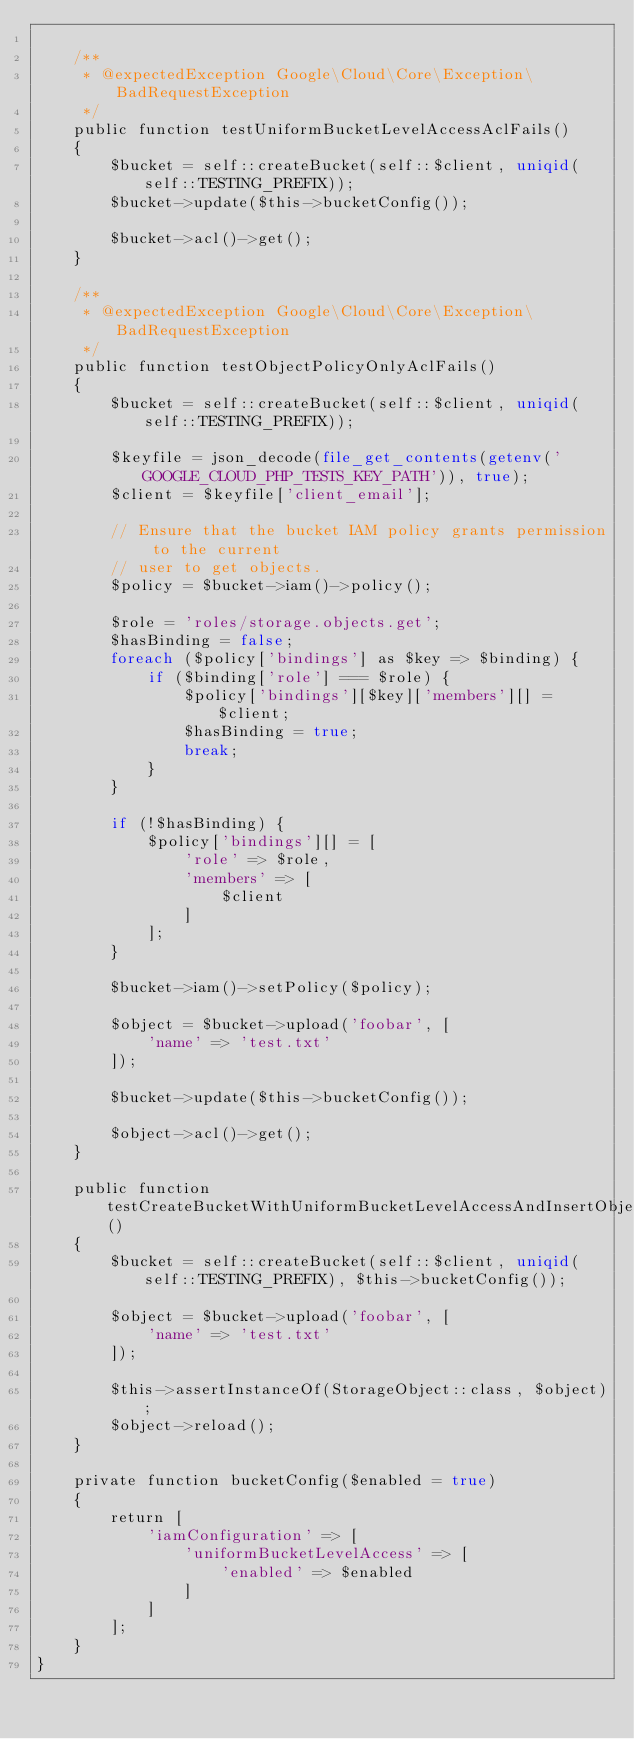Convert code to text. <code><loc_0><loc_0><loc_500><loc_500><_PHP_>
    /**
     * @expectedException Google\Cloud\Core\Exception\BadRequestException
     */
    public function testUniformBucketLevelAccessAclFails()
    {
        $bucket = self::createBucket(self::$client, uniqid(self::TESTING_PREFIX));
        $bucket->update($this->bucketConfig());

        $bucket->acl()->get();
    }

    /**
     * @expectedException Google\Cloud\Core\Exception\BadRequestException
     */
    public function testObjectPolicyOnlyAclFails()
    {
        $bucket = self::createBucket(self::$client, uniqid(self::TESTING_PREFIX));

        $keyfile = json_decode(file_get_contents(getenv('GOOGLE_CLOUD_PHP_TESTS_KEY_PATH')), true);
        $client = $keyfile['client_email'];

        // Ensure that the bucket IAM policy grants permission to the current
        // user to get objects.
        $policy = $bucket->iam()->policy();

        $role = 'roles/storage.objects.get';
        $hasBinding = false;
        foreach ($policy['bindings'] as $key => $binding) {
            if ($binding['role'] === $role) {
                $policy['bindings'][$key]['members'][] = $client;
                $hasBinding = true;
                break;
            }
        }

        if (!$hasBinding) {
            $policy['bindings'][] = [
                'role' => $role,
                'members' => [
                    $client
                ]
            ];
        }

        $bucket->iam()->setPolicy($policy);

        $object = $bucket->upload('foobar', [
            'name' => 'test.txt'
        ]);

        $bucket->update($this->bucketConfig());

        $object->acl()->get();
    }

    public function testCreateBucketWithUniformBucketLevelAccessAndInsertObject()
    {
        $bucket = self::createBucket(self::$client, uniqid(self::TESTING_PREFIX), $this->bucketConfig());

        $object = $bucket->upload('foobar', [
            'name' => 'test.txt'
        ]);

        $this->assertInstanceOf(StorageObject::class, $object);
        $object->reload();
    }

    private function bucketConfig($enabled = true)
    {
        return [
            'iamConfiguration' => [
                'uniformBucketLevelAccess' => [
                    'enabled' => $enabled
                ]
            ]
        ];
    }
}
</code> 